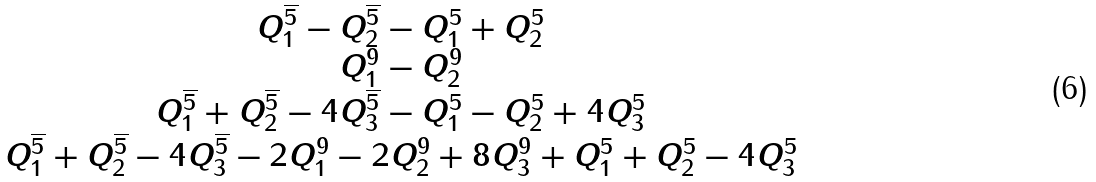<formula> <loc_0><loc_0><loc_500><loc_500>\begin{array} { c } Q _ { 1 } ^ { \overline { 5 } } - Q _ { 2 } ^ { \overline { 5 } } - Q _ { 1 } ^ { 5 } + Q _ { 2 } ^ { 5 } \\ Q _ { 1 } ^ { 9 } - Q _ { 2 } ^ { 9 } \\ Q _ { 1 } ^ { \overline { 5 } } + Q _ { 2 } ^ { \overline { 5 } } - 4 Q _ { 3 } ^ { \overline { 5 } } - Q _ { 1 } ^ { 5 } - Q _ { 2 } ^ { 5 } + 4 Q _ { 3 } ^ { 5 } \\ Q _ { 1 } ^ { \overline { 5 } } + Q _ { 2 } ^ { \overline { 5 } } - 4 Q _ { 3 } ^ { \overline { 5 } } - 2 Q _ { 1 } ^ { 9 } - 2 Q _ { 2 } ^ { 9 } + 8 Q _ { 3 } ^ { 9 } + Q _ { 1 } ^ { 5 } + Q _ { 2 } ^ { 5 } - 4 Q _ { 3 } ^ { 5 } \\ \end{array}</formula> 